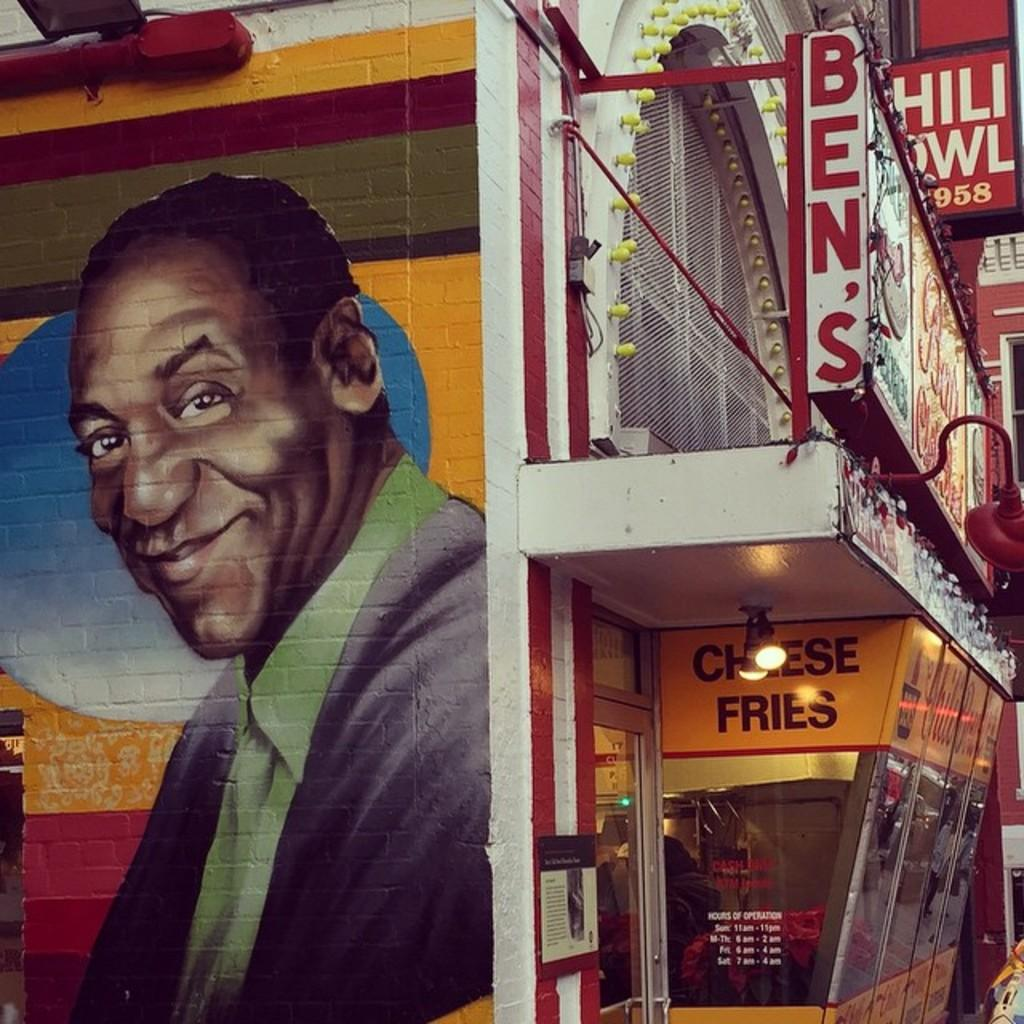What type of structures can be seen in the image? There are buildings in the image. What is the purpose of the fence in the image? The purpose of the fence in the image is not explicitly stated, but it could be to mark a boundary or provide security. What is hanging in the image? There is a banner in the image. What type of illumination is present in the image? There is a light in the image. What is depicted in the drawing in the image? There is a drawing of a man in the image. What color is the jacket worn by the man in the drawing? The man in the drawing is wearing a black color jacket. What is the brother of the man in the drawing doing in the image? There is no mention of a brother in the image or the facts provided. Is the man in the drawing taking a bath in the image? There is no indication of a bath or any bathing-related activity in the image or the facts provided. 